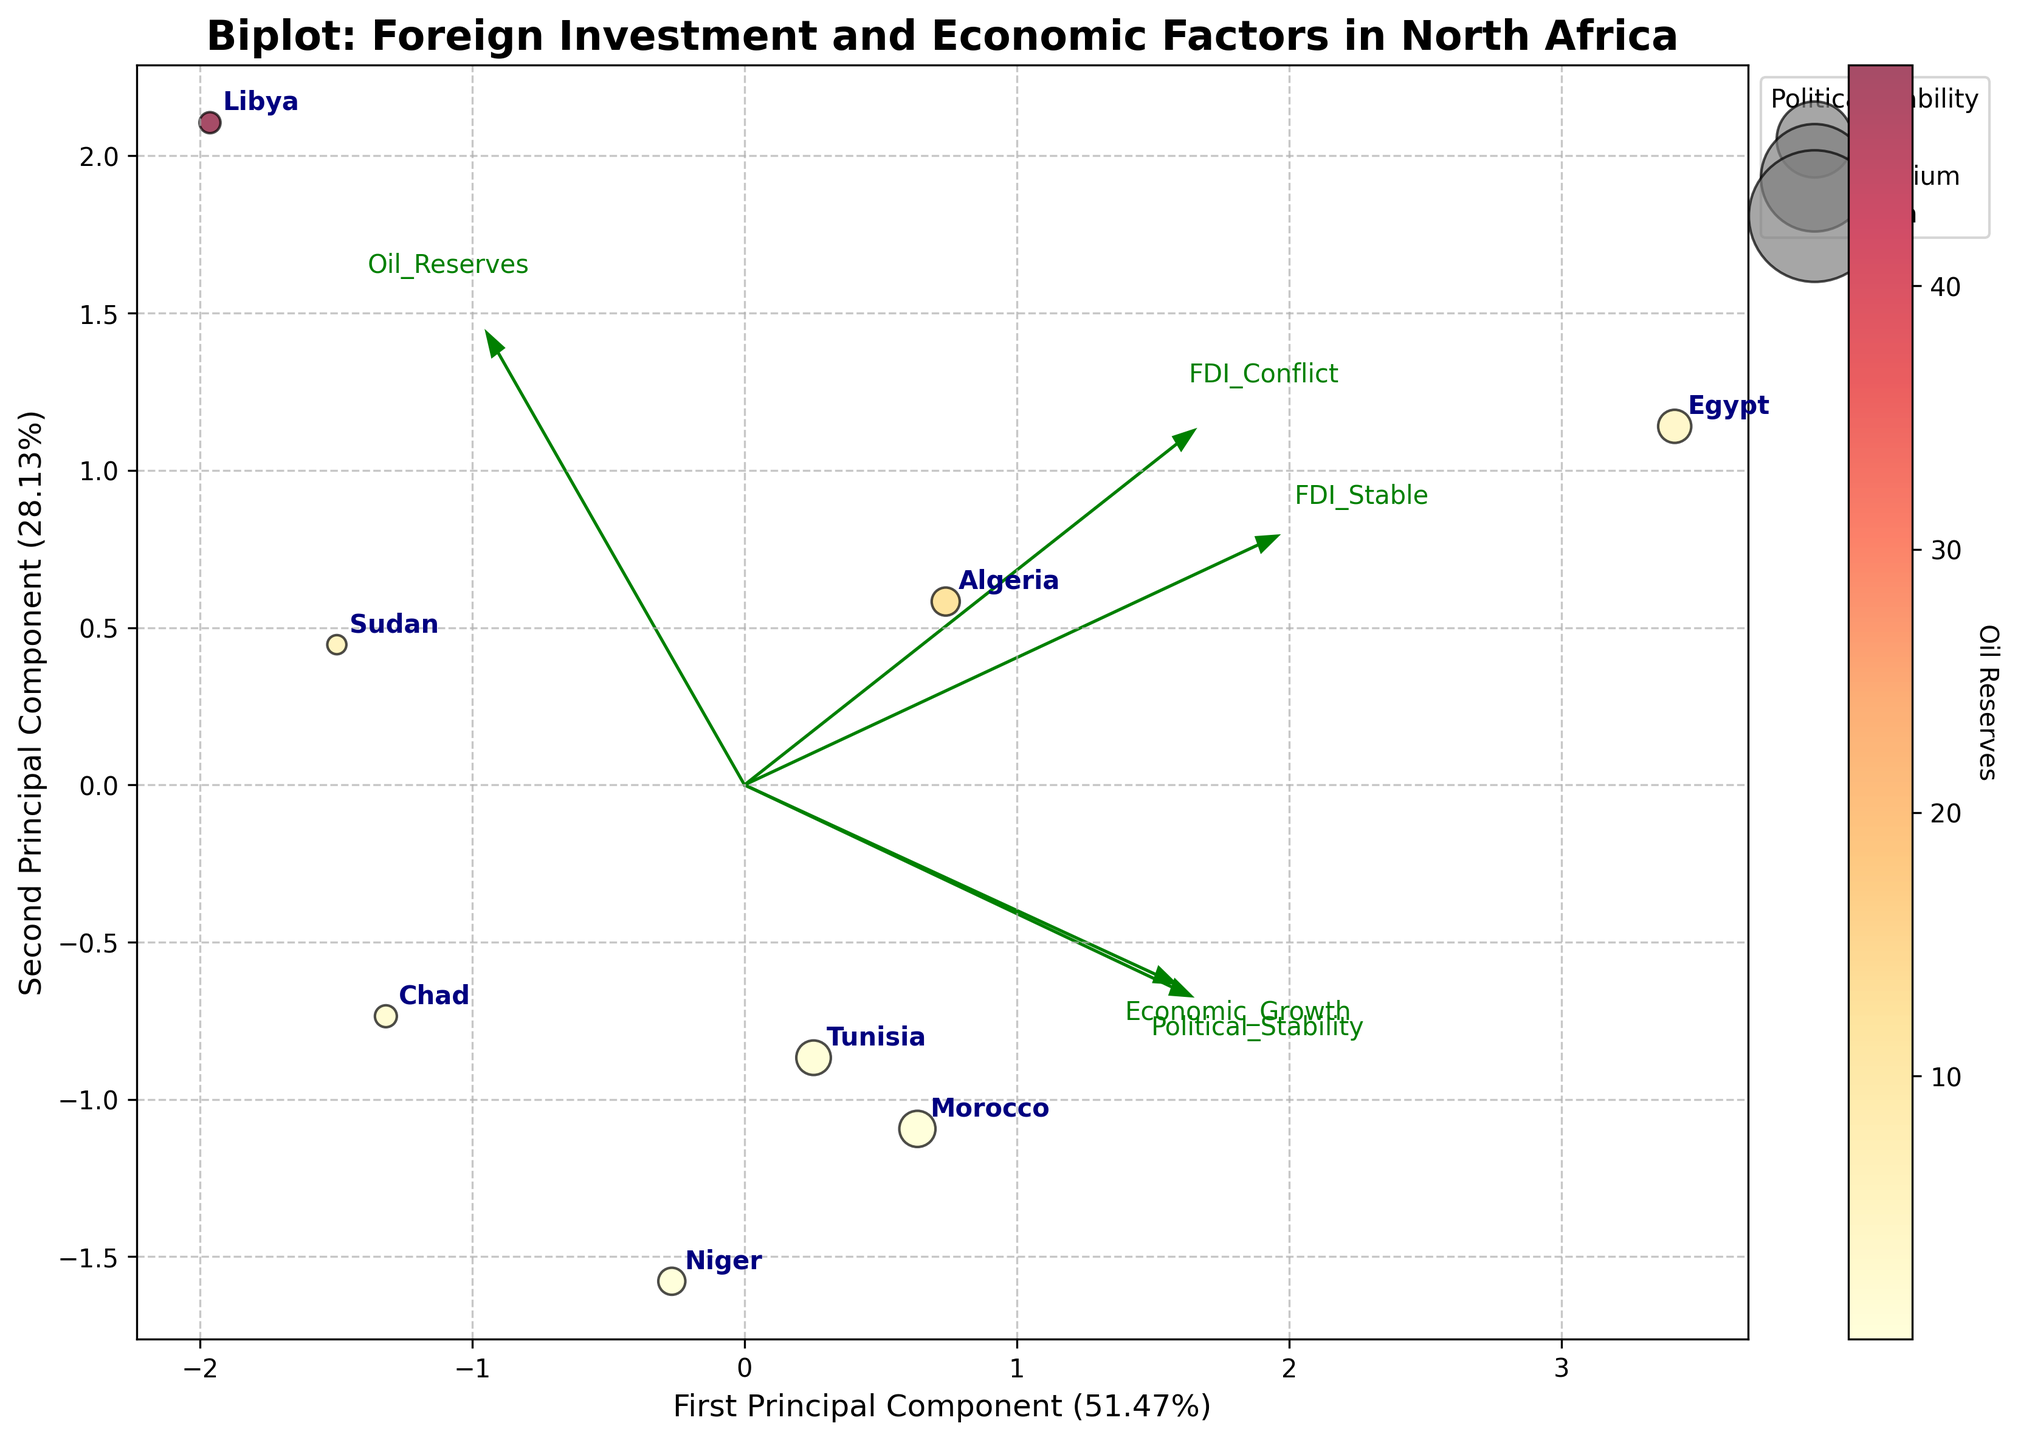What is the title of the biplot? The title of the biplot is located at the top center of the figure.
Answer: Biplot: Foreign Investment and Economic Factors in North Africa How many countries are represented in the biplot? Each data point in the biplot represents a country. Counting these points gives the total number of countries.
Answer: 8 Which country has the highest political stability according to the biplot? The size of the bubbles is proportional to the political stability. The largest bubble can be identified as having the highest political stability.
Answer: Morocco Which country has the lowest FDI in conflict-prone areas? The countries are labeled on the biplot, and the axes represent the principal components derived from the investment data. Identify the country located lowest along the relevant axis for FDI in conflict-prone areas.
Answer: Niger How does the direction of the Political Stability vector compare to the Economic Growth vector? The direction of each vector can be observed in the biplot. Compare the arrows representing Political Stability and Economic Growth.
Answer: Both point in a similar direction Which country has the highest oil reserves according to the color of the bubbles? The color of the bubbles indicates oil reserves, with a color bar showing the scale from low to high. Identify the country with the darkest color.
Answer: Libya Specifically, what relationship can be derived from the First Principal Component and FDI_Stable? The biplot shows the vectors of the original variables. The relationship is indicated by the direction and length of the FDI_Stable vector along the first principal component axis.
Answer: Positive relationship Which two countries are closest together on the biplot? Examine the positions of all countries and identify the pair that are closest to each other.
Answer: Algeria and Tunisia 